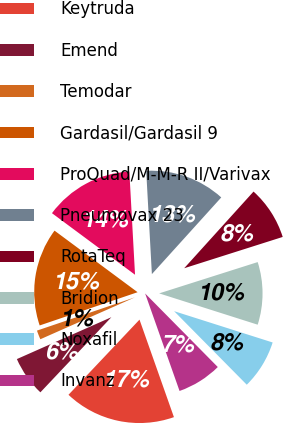<chart> <loc_0><loc_0><loc_500><loc_500><pie_chart><fcel>Keytruda<fcel>Emend<fcel>Temodar<fcel>Gardasil/Gardasil 9<fcel>ProQuad/M-M-R II/Varivax<fcel>Pneumovax 23<fcel>RotaTeq<fcel>Bridion<fcel>Noxafil<fcel>Invanz<nl><fcel>17.45%<fcel>6.31%<fcel>1.43%<fcel>15.36%<fcel>13.97%<fcel>12.58%<fcel>8.4%<fcel>9.79%<fcel>7.7%<fcel>7.0%<nl></chart> 